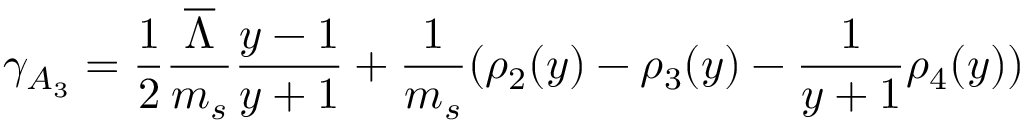<formula> <loc_0><loc_0><loc_500><loc_500>\gamma _ { A _ { 3 } } = { \frac { 1 } { 2 } } { \frac { \overline { \Lambda } } { m _ { s } } } { \frac { y - 1 } { y + 1 } } + { \frac { 1 } { m _ { s } } } ( \rho _ { 2 } ( y ) - \rho _ { 3 } ( y ) - { \frac { 1 } { y + 1 } } \rho _ { 4 } ( y ) )</formula> 